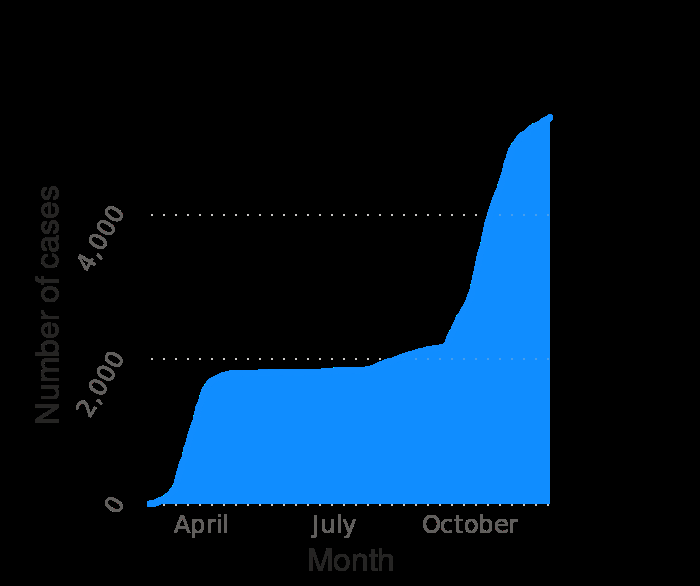<image>
What is the latest date mentioned in the graph? The latest date mentioned in the graph is November 25, 2020. Describe the following image in detail Cumulative number of coronavirus (COVID-19) cases in Iceland since February 2020 (as of November 25 , 2020) is a area plot. A categorical scale starting with April and ending with October can be found along the x-axis, labeled Month. A linear scale from 0 to 4,000 can be seen on the y-axis, marked Number of cases. Offer a thorough analysis of the image. The total number of cases went from zero to 1,800 in an almost linear fashion, during the months of February and March and then plateaued until the month of August. And from then, the number of cases slowly increased to 2,200 by the end of August, then shooting up dramatically from September onwards, reaching about 6,000 by 25th November. When did the number of cases start to increase dramatically?  The number of cases started to increase dramatically from September onwards. 